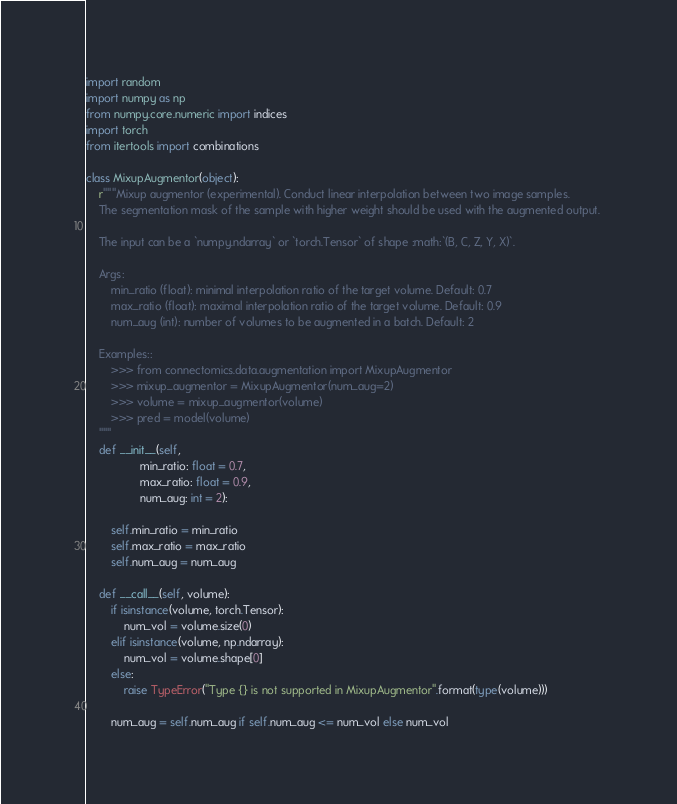Convert code to text. <code><loc_0><loc_0><loc_500><loc_500><_Python_>import random
import numpy as np
from numpy.core.numeric import indices
import torch
from itertools import combinations

class MixupAugmentor(object):
    r"""Mixup augmentor (experimental). Conduct linear interpolation between two image samples. 
    The segmentation mask of the sample with higher weight should be used with the augmented output. 

    The input can be a `numpy.ndarray` or `torch.Tensor` of shape :math:`(B, C, Z, Y, X)`.
    
    Args:
        min_ratio (float): minimal interpolation ratio of the target volume. Default: 0.7
        max_ratio (float): maximal interpolation ratio of the target volume. Default: 0.9
        num_aug (int): number of volumes to be augmented in a batch. Default: 2

    Examples::
        >>> from connectomics.data.augmentation import MixupAugmentor
        >>> mixup_augmentor = MixupAugmentor(num_aug=2)
        >>> volume = mixup_augmentor(volume)
        >>> pred = model(volume)
    """  
    def __init__(self, 
                 min_ratio: float = 0.7, 
                 max_ratio: float = 0.9, 
                 num_aug: int = 2):

        self.min_ratio = min_ratio
        self.max_ratio = max_ratio
        self.num_aug = num_aug

    def __call__(self, volume):
        if isinstance(volume, torch.Tensor):
            num_vol = volume.size(0)
        elif isinstance(volume, np.ndarray):
            num_vol = volume.shape[0]
        else:
            raise TypeError("Type {} is not supported in MixupAugmentor".format(type(volume)))

        num_aug = self.num_aug if self.num_aug <= num_vol else num_vol</code> 